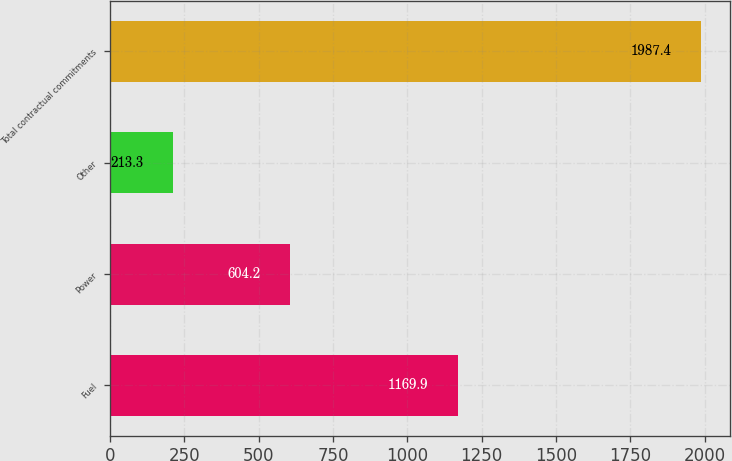Convert chart to OTSL. <chart><loc_0><loc_0><loc_500><loc_500><bar_chart><fcel>Fuel<fcel>Power<fcel>Other<fcel>Total contractual commitments<nl><fcel>1169.9<fcel>604.2<fcel>213.3<fcel>1987.4<nl></chart> 